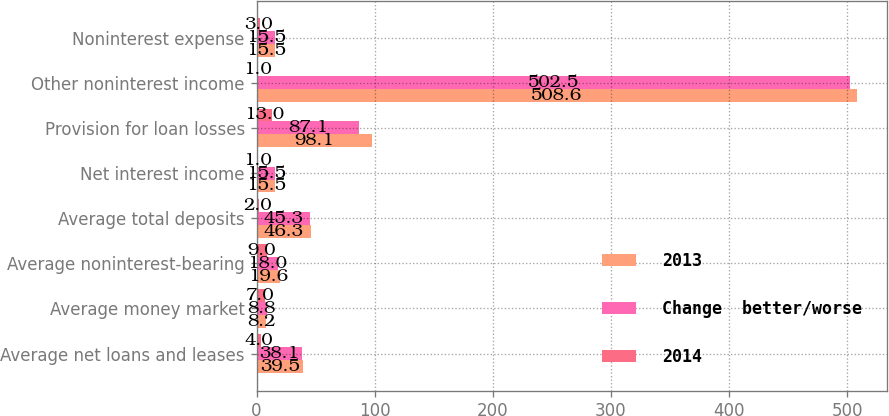Convert chart. <chart><loc_0><loc_0><loc_500><loc_500><stacked_bar_chart><ecel><fcel>Average net loans and leases<fcel>Average money market<fcel>Average noninterest-bearing<fcel>Average total deposits<fcel>Net interest income<fcel>Provision for loan losses<fcel>Other noninterest income<fcel>Noninterest expense<nl><fcel>2013<fcel>39.5<fcel>8.2<fcel>19.6<fcel>46.3<fcel>15.5<fcel>98.1<fcel>508.6<fcel>15.5<nl><fcel>Change  better/worse<fcel>38.1<fcel>8.8<fcel>18<fcel>45.3<fcel>15.5<fcel>87.1<fcel>502.5<fcel>15.5<nl><fcel>2014<fcel>4<fcel>7<fcel>9<fcel>2<fcel>1<fcel>13<fcel>1<fcel>3<nl></chart> 